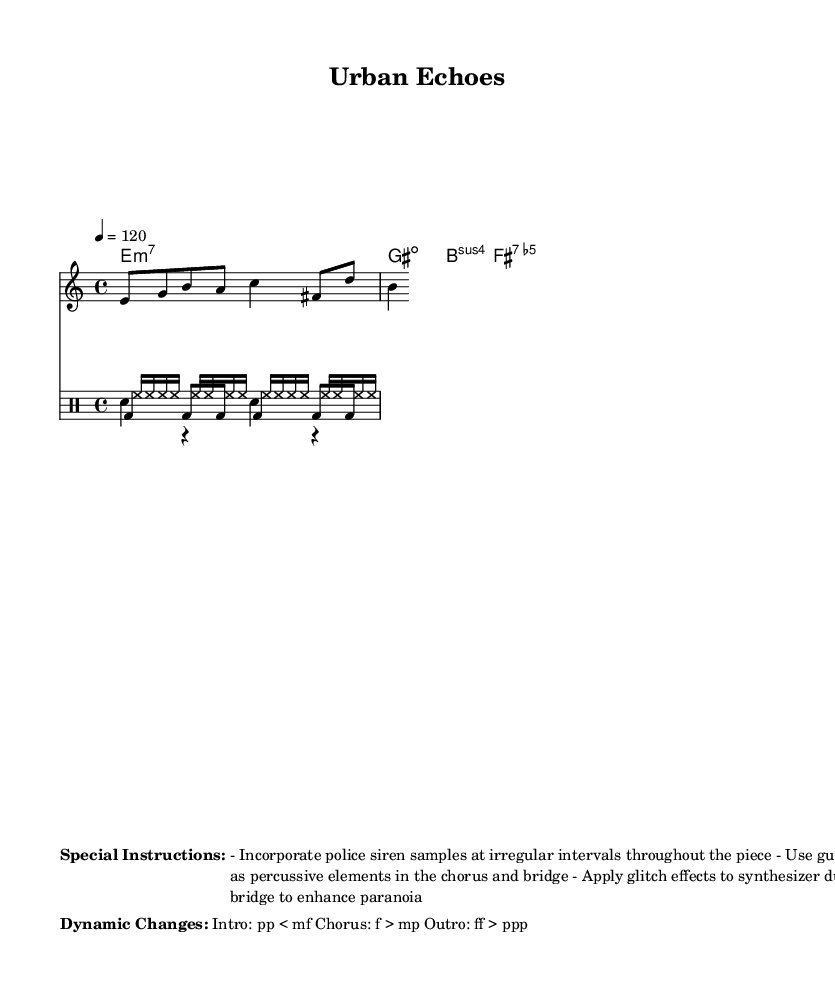What is the tempo marking for this piece? The tempo marking indicates the speed of the piece, which is set at 120 beats per minute, as indicated by the tempo directive.
Answer: 120 What is the time signature of this music? The time signature, shown at the beginning of the score, is 4/4, which means there are four beats in each measure.
Answer: 4/4 What is the first chord in the harmony? The first chord listed under the chord names is E minor seven, denoted by "e1:m7" in the chord notation.
Answer: E minor seven What dynamic marking is assigned to the chorus section? The dynamic changes section states that the chorus should be played loud, indicated by the marking "f," which stands for fortissimo.
Answer: f How are the police sirens incorporated into the music? The special instructions state that police siren samples should be incorporated at irregular intervals, indicating the unconventional structure typical of AVANT-GARDE music.
Answer: Irregular intervals What is the effect applied to the synthesizer during the bridge? The special instructions specify that glitch effects should be applied to the synthesizer during the bridge, enhancing the music's theme of paranoia.
Answer: Glitch effects What is the final dynamic marking indicated in the music? The final dynamic marking for the outro section indicates a very soft sound, marked "ppp," which stands for pianississimo.
Answer: ppp 